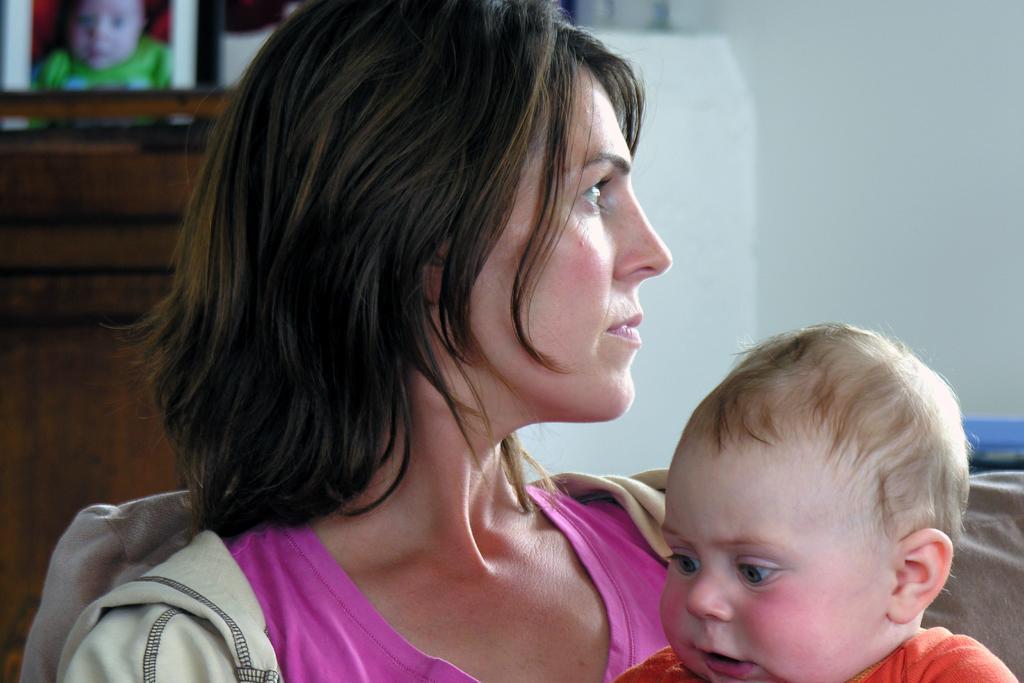Please provide a concise description of this image. In this image I can see a woman wearing pink and ash color dress is sitting on a couch and holding a baby wearing orange colored dress. In the background I can see the white colored wall and a photo frame. 